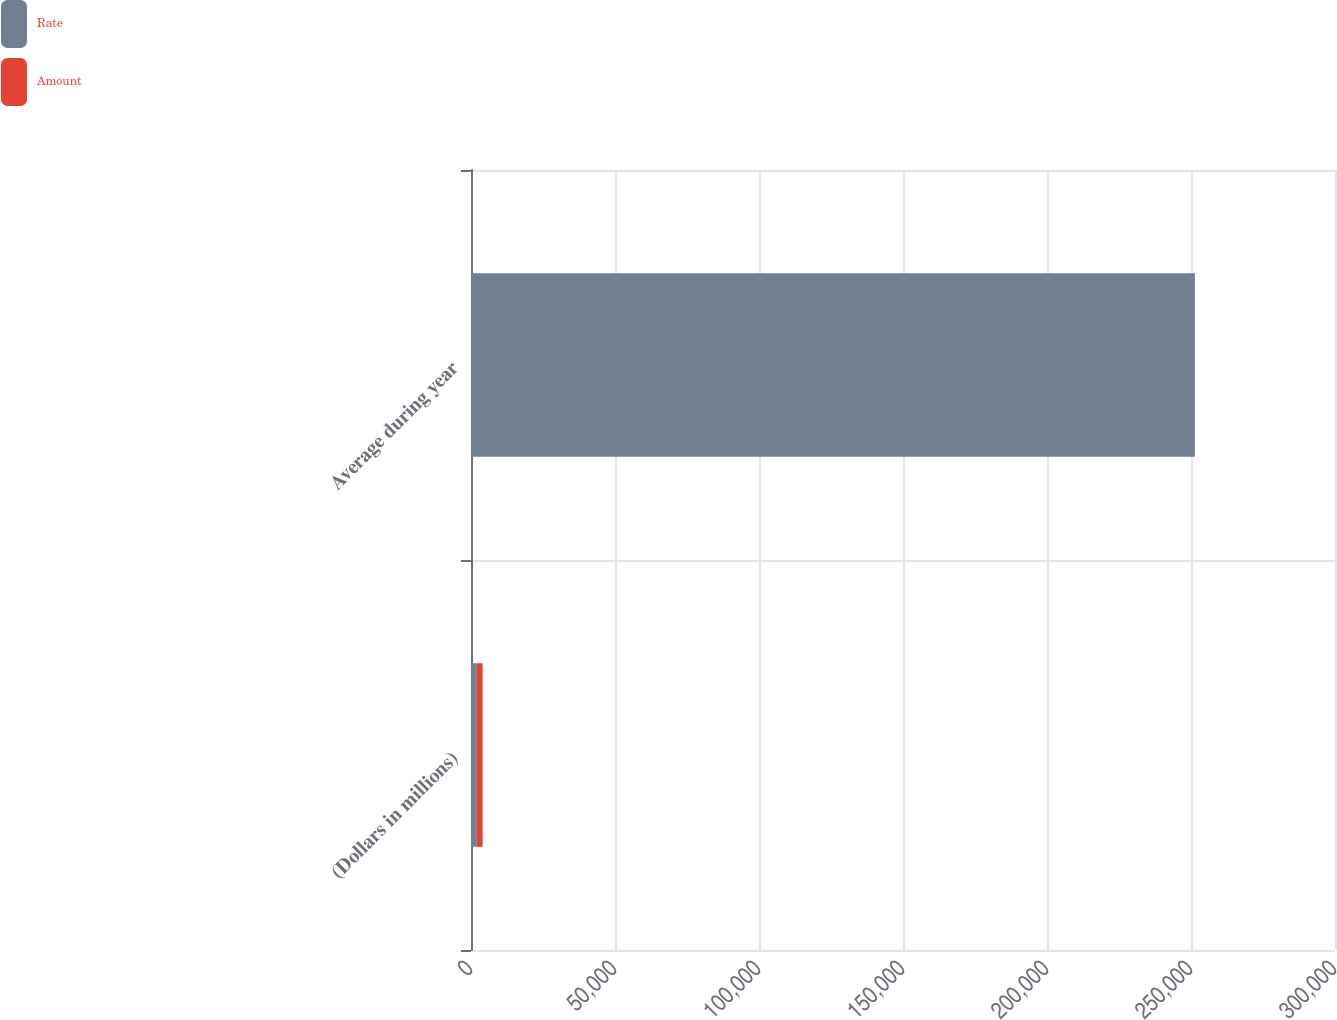Convert chart. <chart><loc_0><loc_0><loc_500><loc_500><stacked_bar_chart><ecel><fcel>(Dollars in millions)<fcel>Average during year<nl><fcel>Rate<fcel>2018<fcel>251328<nl><fcel>Amount<fcel>2018<fcel>1.26<nl></chart> 